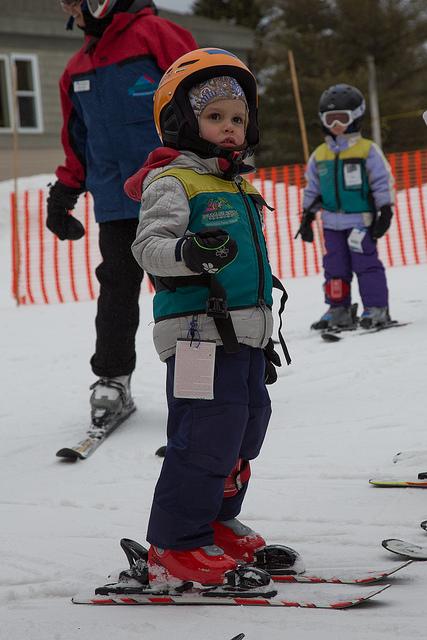What is the gender of child?
Quick response, please. Girl. Is she skiing?
Concise answer only. Yes. Does the child's gloves match his coat?
Keep it brief. No. What is the person wearing over their eyes?
Short answer required. Goggles. How many little kids have skis on?
Write a very short answer. 2. What color are the skiis?
Write a very short answer. Red. What is the weather like on this day?
Give a very brief answer. Cold. What color is the kid's gloves?
Quick response, please. Black. Where are there mother?
Be succinct. Behind them. What is on the ground?
Be succinct. Snow. 